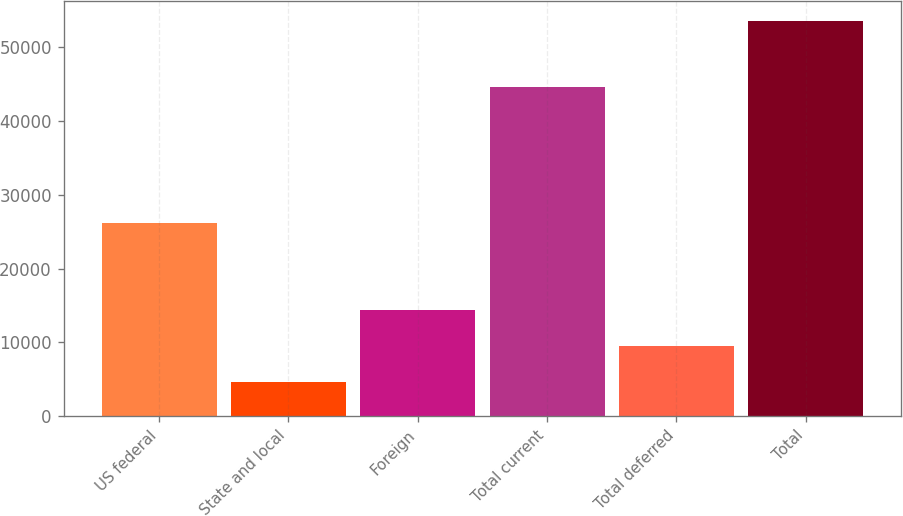Convert chart. <chart><loc_0><loc_0><loc_500><loc_500><bar_chart><fcel>US federal<fcel>State and local<fcel>Foreign<fcel>Total current<fcel>Total deferred<fcel>Total<nl><fcel>26204<fcel>4583<fcel>14386.2<fcel>44562<fcel>9484.6<fcel>53599<nl></chart> 